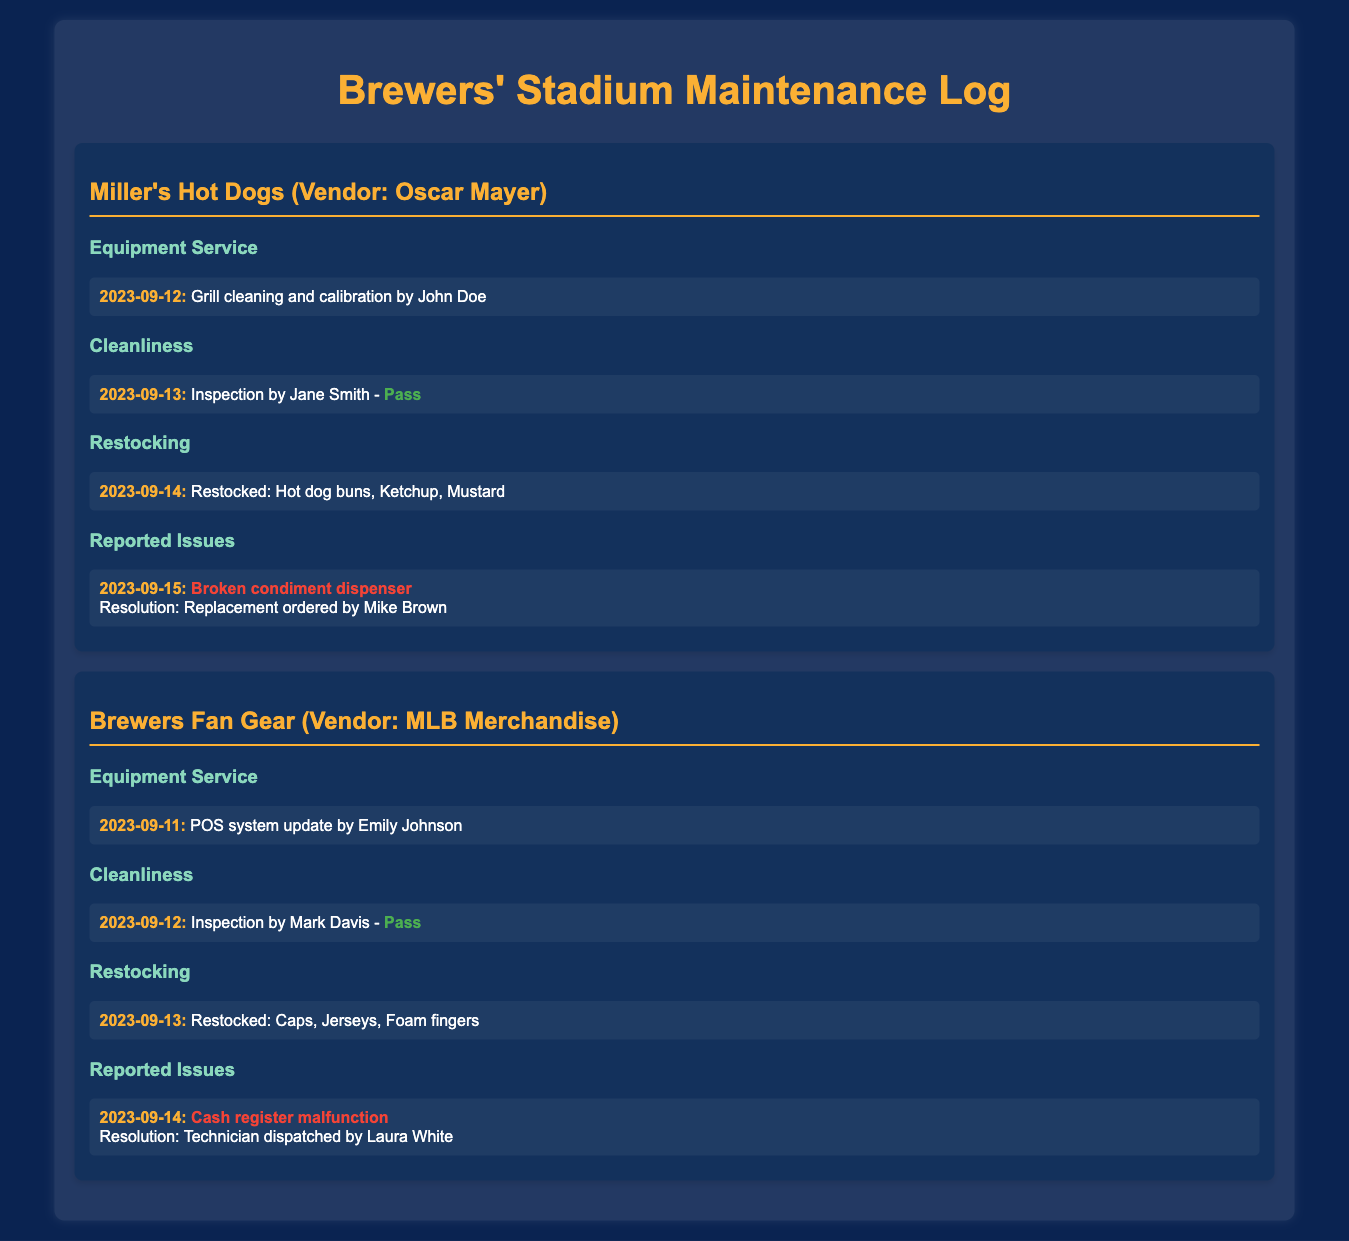what vendor supplies Miller's Hot Dogs? The document states that Miller's Hot Dogs is supplied by Oscar Mayer.
Answer: Oscar Mayer when was the last cleanliness inspection for Brewers Fan Gear? The inspection for Brewers Fan Gear was conducted on September 12, 2023, by Mark Davis.
Answer: 2023-09-12 what issue was reported at Miller's Hot Dogs? A broken condiment dispenser was reported along with the resolution details.
Answer: Broken condiment dispenser who dispatched the technician for the cash register malfunction? The technician for the cash register malfunction was dispatched by Laura White.
Answer: Laura White how many items were restocked for Miller's Hot Dogs? The restocking log mentions three items: hot dog buns, ketchup, and mustard.
Answer: 3 what type of inspection did Brewers Fan Gear pass? The cleanliness inspection for Brewers Fan Gear by Mark Davis was categorized as a pass.
Answer: Pass when was the POS system updated for Brewers Fan Gear? The POS system update was completed on September 11, 2023, by Emily Johnson.
Answer: 2023-09-11 who performed the grill cleaning at Miller's Hot Dogs? The grill cleaning and calibration were performed by John Doe.
Answer: John Doe what was restocked on September 13 at Brewers Fan Gear? The restocking on September 13 included caps, jerseys, and foam fingers.
Answer: Caps, Jerseys, Foam fingers 